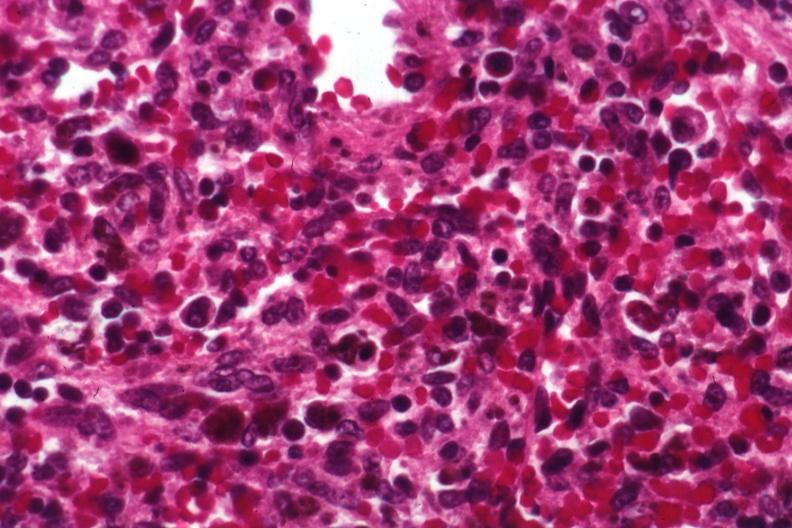what is present?
Answer the question using a single word or phrase. Hematologic 